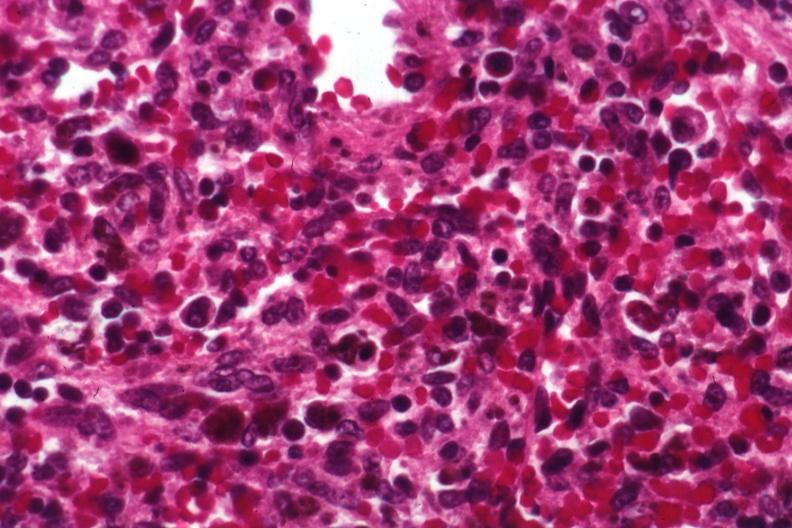what is present?
Answer the question using a single word or phrase. Hematologic 